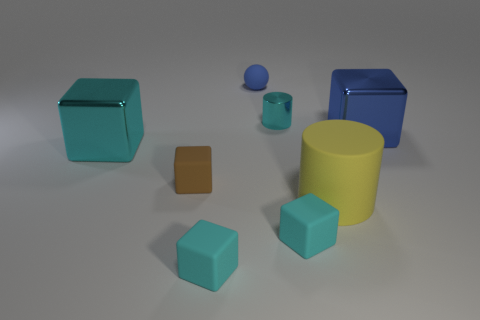Is the number of cyan metallic cubes on the left side of the cyan shiny cube the same as the number of small blue matte cubes?
Your answer should be very brief. Yes. Do the cyan shiny cube and the blue metal object have the same size?
Ensure brevity in your answer.  Yes. What number of rubber objects are tiny spheres or cyan cylinders?
Your answer should be compact. 1. There is a brown object that is the same size as the matte ball; what is it made of?
Your answer should be compact. Rubber. How many other objects are the same material as the small brown thing?
Ensure brevity in your answer.  4. Are there fewer blue spheres in front of the big cylinder than big shiny cylinders?
Provide a short and direct response. No. Is the yellow rubber thing the same shape as the small metal object?
Your response must be concise. Yes. What size is the metal object that is behind the large cube on the right side of the cyan cube behind the large yellow cylinder?
Provide a succinct answer. Small. What material is the other object that is the same shape as the small cyan metallic thing?
Make the answer very short. Rubber. How big is the rubber object behind the large cyan thing that is behind the tiny brown object?
Your response must be concise. Small. 